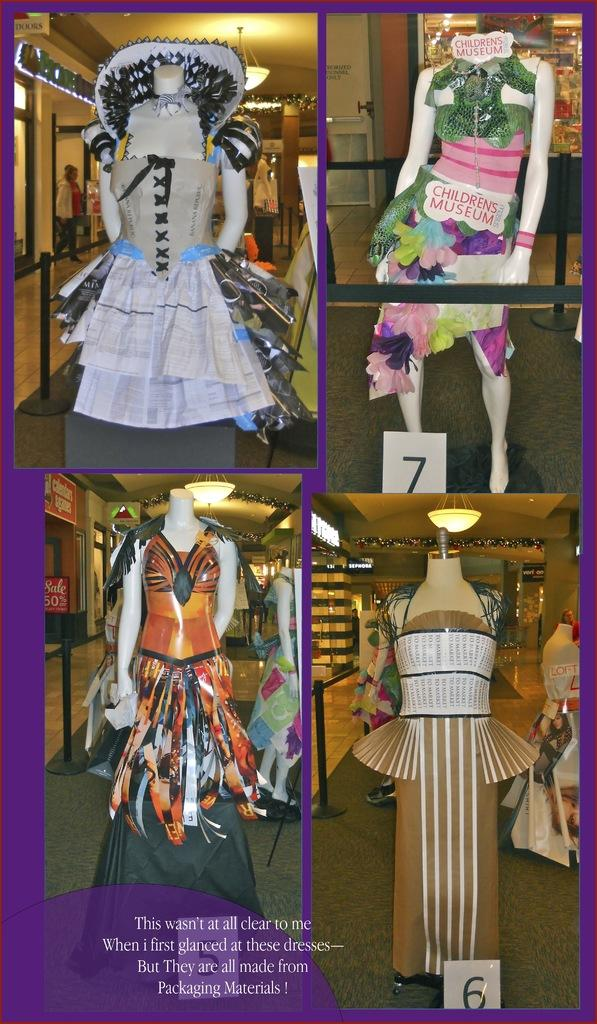What is the main subject of the poster in the image? The main subject of the poster in the image is a collection of five images, each containing a doll. What can be observed about the dolls in the images? The dolls have different colored dresses. What type of text is present on the poster? There is white text on the poster. What is the color of the background on the poster? The background of the poster is violet in color. Can you tell me how many matches are being played by the dolls in the image? There are no matches being played by the dolls in the image; the dolls are simply depicted in different images with different colored dresses. How many dolls are jumping in the image? There are no dolls jumping in the image; they are all standing or sitting in their respective images. 